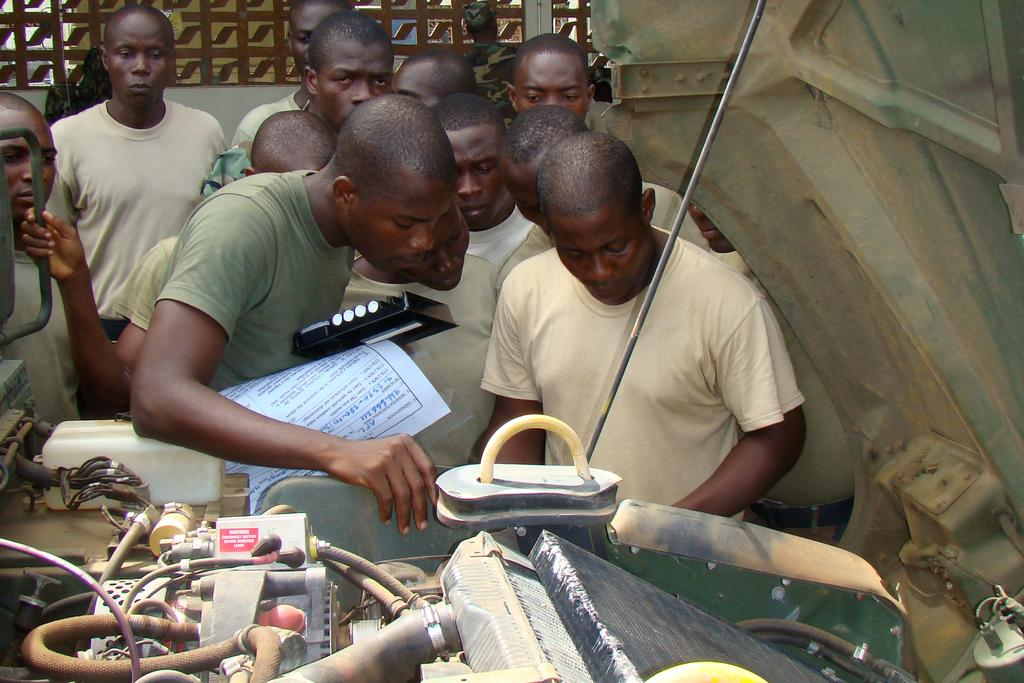What type of men are in the image? There are bald headed men in the image. What are the men wearing? The men are wearing grey t-shirts. What are the men doing in front of the vehicle? The men are standing in front of a vehicle with its hood open and inspecting the engine. What can be seen in the background of the image? There is a wall visible in the background of the image. What type of wax is being used by the men to polish the vehicle's hood? There is no wax present in the image, nor is there any indication that the men are polishing the vehicle's hood. 